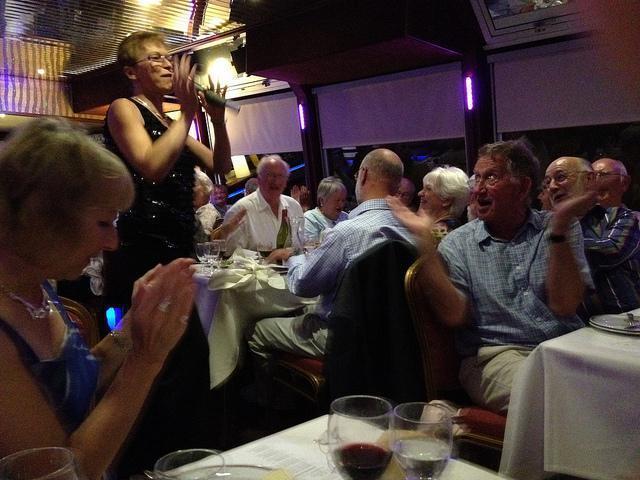What is the entertainment tonight for the people eating dinner?
Select the accurate response from the four choices given to answer the question.
Options: Acrobats, movie, live singing, magic show. Live singing. 